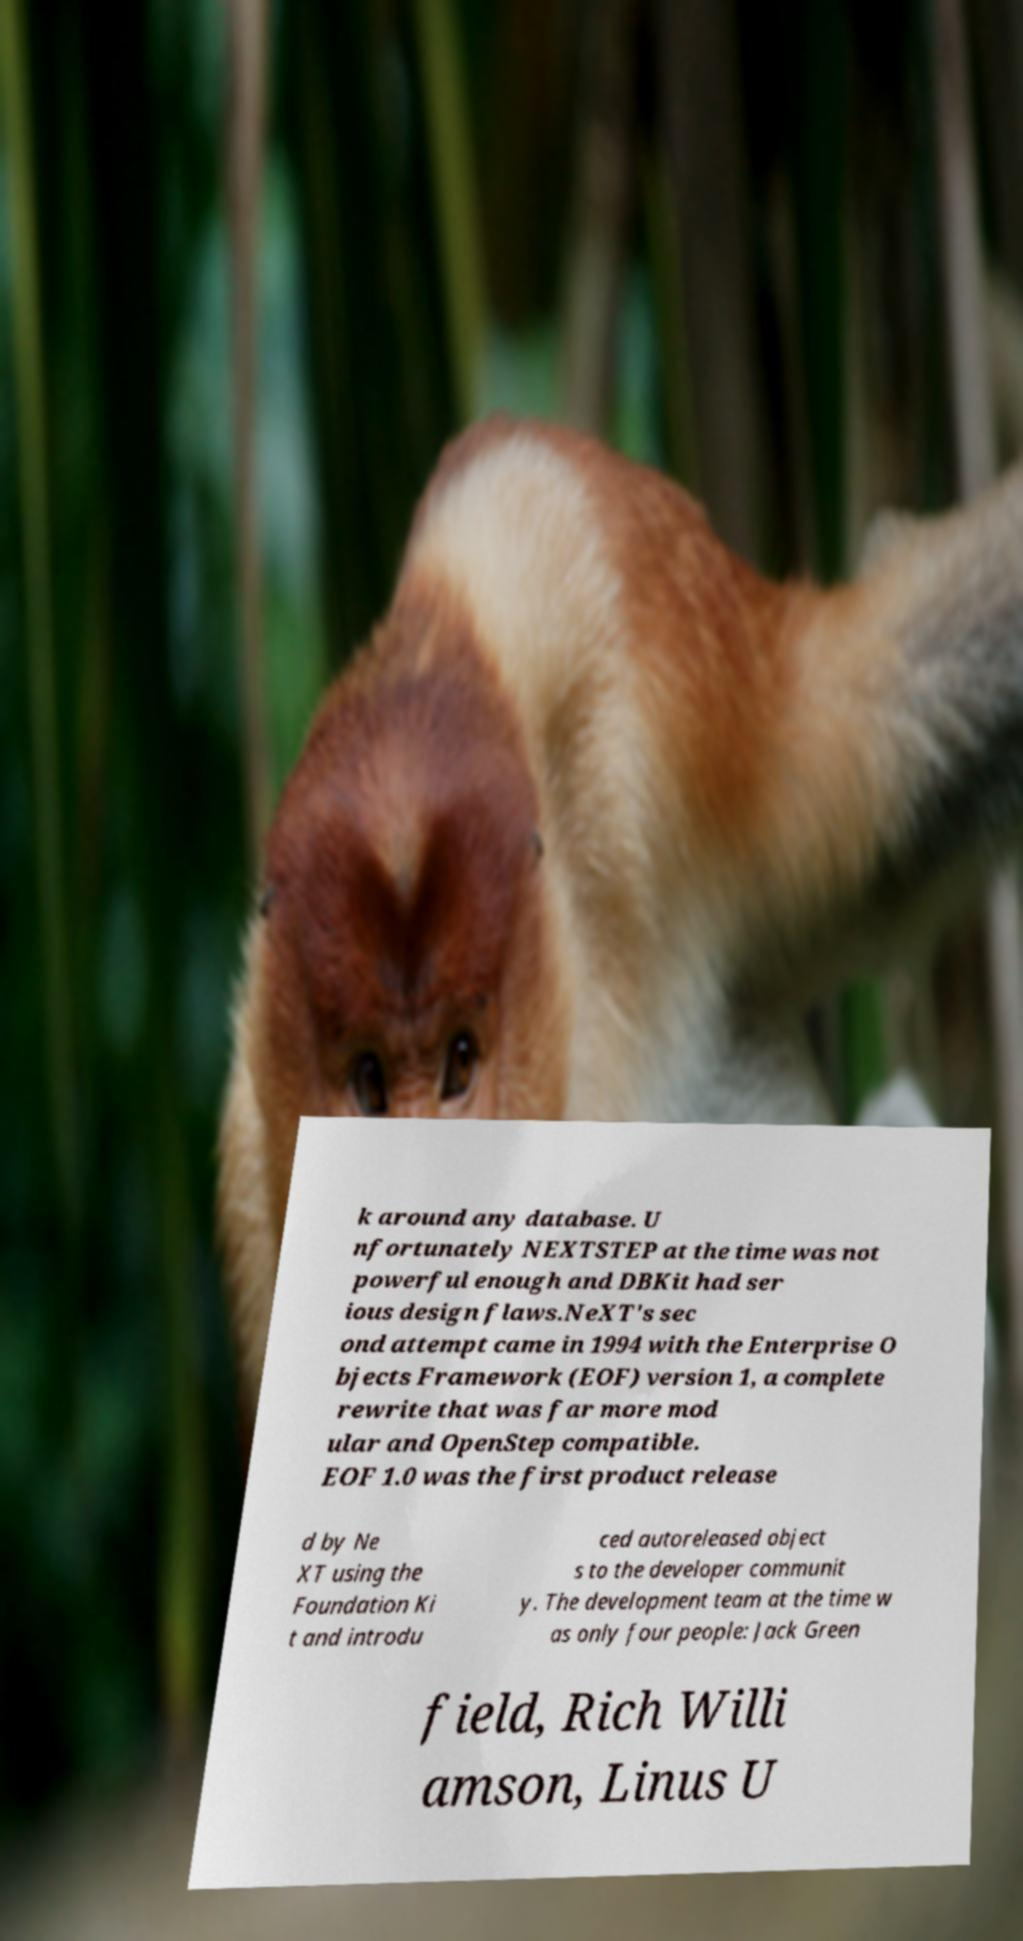Can you read and provide the text displayed in the image?This photo seems to have some interesting text. Can you extract and type it out for me? k around any database. U nfortunately NEXTSTEP at the time was not powerful enough and DBKit had ser ious design flaws.NeXT's sec ond attempt came in 1994 with the Enterprise O bjects Framework (EOF) version 1, a complete rewrite that was far more mod ular and OpenStep compatible. EOF 1.0 was the first product release d by Ne XT using the Foundation Ki t and introdu ced autoreleased object s to the developer communit y. The development team at the time w as only four people: Jack Green field, Rich Willi amson, Linus U 